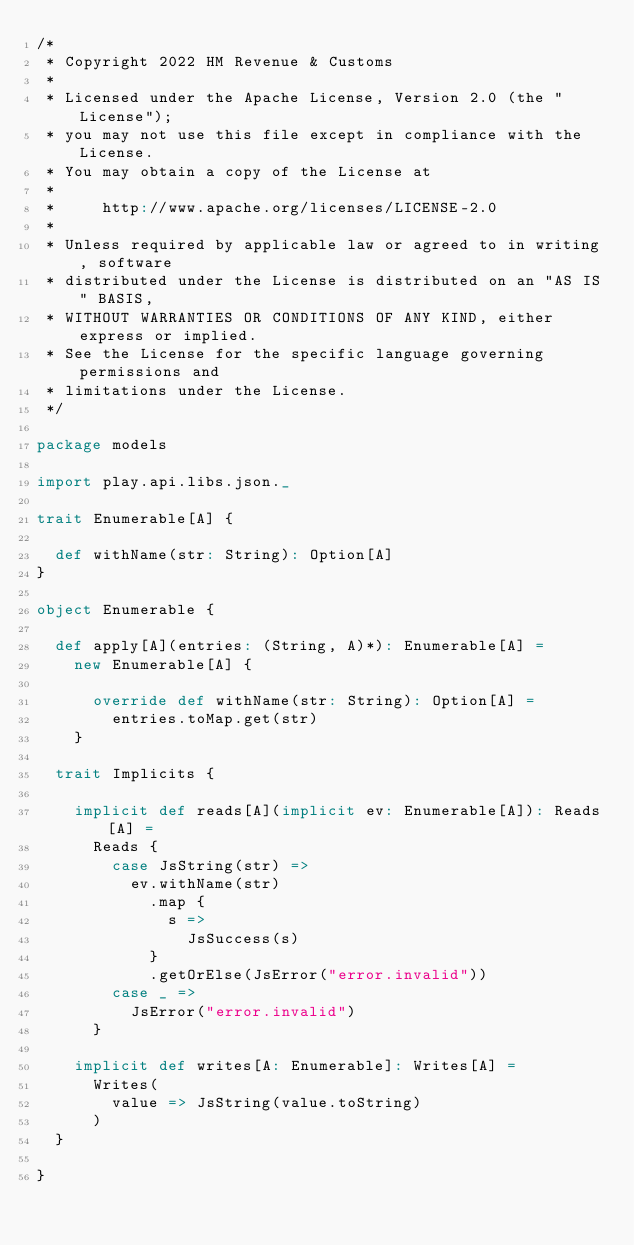<code> <loc_0><loc_0><loc_500><loc_500><_Scala_>/*
 * Copyright 2022 HM Revenue & Customs
 *
 * Licensed under the Apache License, Version 2.0 (the "License");
 * you may not use this file except in compliance with the License.
 * You may obtain a copy of the License at
 *
 *     http://www.apache.org/licenses/LICENSE-2.0
 *
 * Unless required by applicable law or agreed to in writing, software
 * distributed under the License is distributed on an "AS IS" BASIS,
 * WITHOUT WARRANTIES OR CONDITIONS OF ANY KIND, either express or implied.
 * See the License for the specific language governing permissions and
 * limitations under the License.
 */

package models

import play.api.libs.json._

trait Enumerable[A] {

  def withName(str: String): Option[A]
}

object Enumerable {

  def apply[A](entries: (String, A)*): Enumerable[A] =
    new Enumerable[A] {

      override def withName(str: String): Option[A] =
        entries.toMap.get(str)
    }

  trait Implicits {

    implicit def reads[A](implicit ev: Enumerable[A]): Reads[A] =
      Reads {
        case JsString(str) =>
          ev.withName(str)
            .map {
              s =>
                JsSuccess(s)
            }
            .getOrElse(JsError("error.invalid"))
        case _ =>
          JsError("error.invalid")
      }

    implicit def writes[A: Enumerable]: Writes[A] =
      Writes(
        value => JsString(value.toString)
      )
  }

}
</code> 